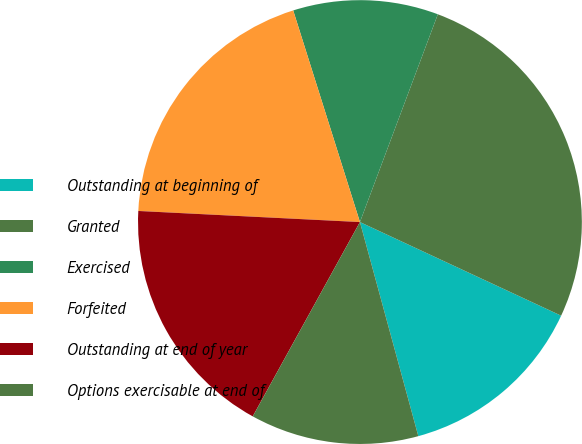Convert chart to OTSL. <chart><loc_0><loc_0><loc_500><loc_500><pie_chart><fcel>Outstanding at beginning of<fcel>Granted<fcel>Exercised<fcel>Forfeited<fcel>Outstanding at end of year<fcel>Options exercisable at end of<nl><fcel>13.83%<fcel>26.22%<fcel>10.57%<fcel>19.34%<fcel>17.77%<fcel>12.26%<nl></chart> 